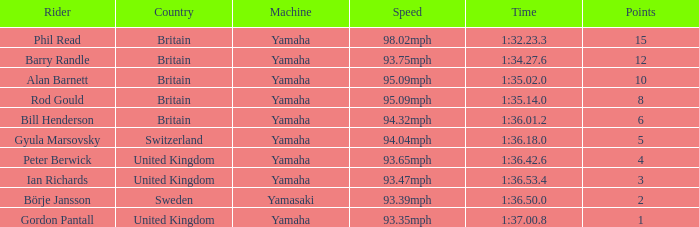What was the duration for the individual who achieved 1 point? 1:37.00.8. 